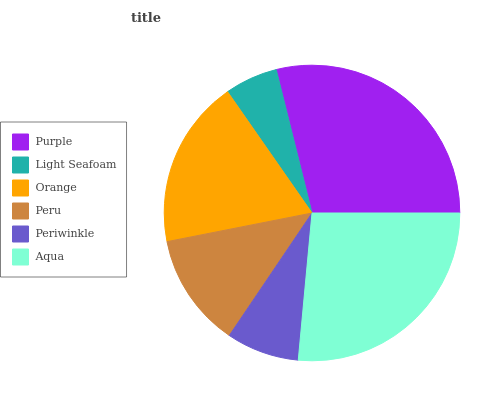Is Light Seafoam the minimum?
Answer yes or no. Yes. Is Purple the maximum?
Answer yes or no. Yes. Is Orange the minimum?
Answer yes or no. No. Is Orange the maximum?
Answer yes or no. No. Is Orange greater than Light Seafoam?
Answer yes or no. Yes. Is Light Seafoam less than Orange?
Answer yes or no. Yes. Is Light Seafoam greater than Orange?
Answer yes or no. No. Is Orange less than Light Seafoam?
Answer yes or no. No. Is Orange the high median?
Answer yes or no. Yes. Is Peru the low median?
Answer yes or no. Yes. Is Periwinkle the high median?
Answer yes or no. No. Is Light Seafoam the low median?
Answer yes or no. No. 